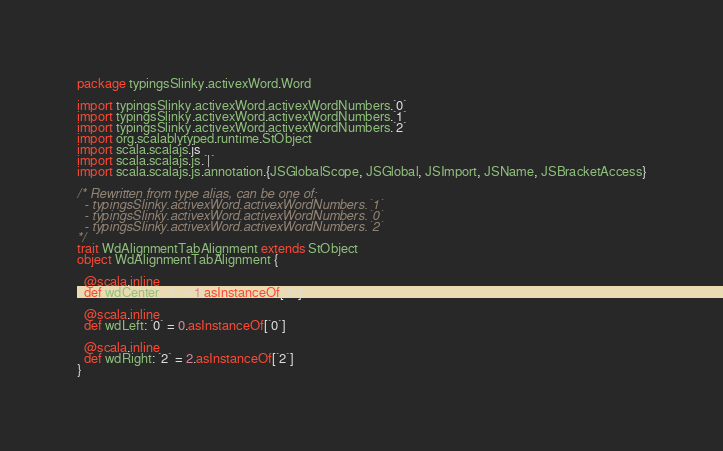Convert code to text. <code><loc_0><loc_0><loc_500><loc_500><_Scala_>package typingsSlinky.activexWord.Word

import typingsSlinky.activexWord.activexWordNumbers.`0`
import typingsSlinky.activexWord.activexWordNumbers.`1`
import typingsSlinky.activexWord.activexWordNumbers.`2`
import org.scalablytyped.runtime.StObject
import scala.scalajs.js
import scala.scalajs.js.`|`
import scala.scalajs.js.annotation.{JSGlobalScope, JSGlobal, JSImport, JSName, JSBracketAccess}

/* Rewritten from type alias, can be one of: 
  - typingsSlinky.activexWord.activexWordNumbers.`1`
  - typingsSlinky.activexWord.activexWordNumbers.`0`
  - typingsSlinky.activexWord.activexWordNumbers.`2`
*/
trait WdAlignmentTabAlignment extends StObject
object WdAlignmentTabAlignment {
  
  @scala.inline
  def wdCenter: `1` = 1.asInstanceOf[`1`]
  
  @scala.inline
  def wdLeft: `0` = 0.asInstanceOf[`0`]
  
  @scala.inline
  def wdRight: `2` = 2.asInstanceOf[`2`]
}
</code> 